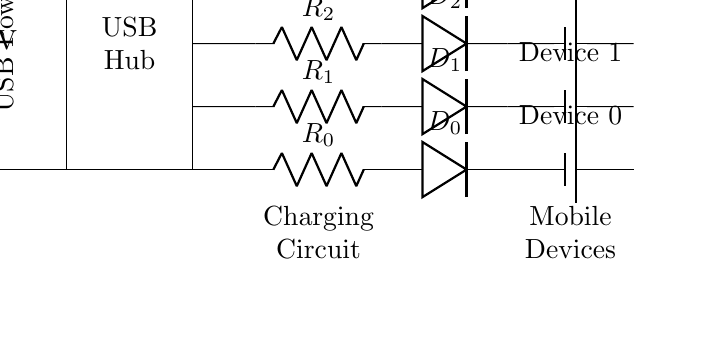What is the voltage source in this circuit? The circuit shows a voltage source labeled as 5V connected at the start of the circuit. This indicates that the entire system is powered by a 5V supply.
Answer: 5V How many charging ports are available in the USB hub? The diagram indicates that there are four charging ports, as represented by the four vertical lines leading to the charging components designated for each mobile device.
Answer: Four What component type is used to protect each device in this circuit? Each device is connected through a diode, which is a protective component that allows current to flow in one direction only, preventing potential damage to the devices from reverse current.
Answer: Diode What is the purpose of the resistors in this circuit? The resistors in the circuit serve to limit the current flowing to each connected device, ensuring that they do not receive too much power, which could cause damage or affect performance.
Answer: Current limiting Which component is used to charge mobile devices? The charging is performed by batteries, indicated in the diagram as battery components, which represent the mobile devices being charged through the hub.
Answer: Battery What is the purpose of the USB hub in this circuit? The USB hub functions as a distribution point that takes the 5V power from the source and allocates it to multiple devices, allowing for simultaneous charging of all mobile devices connected.
Answer: Distribution point 